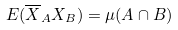Convert formula to latex. <formula><loc_0><loc_0><loc_500><loc_500>E ( \overline { X } _ { A } X _ { B } ) = \mu ( A \cap B )</formula> 